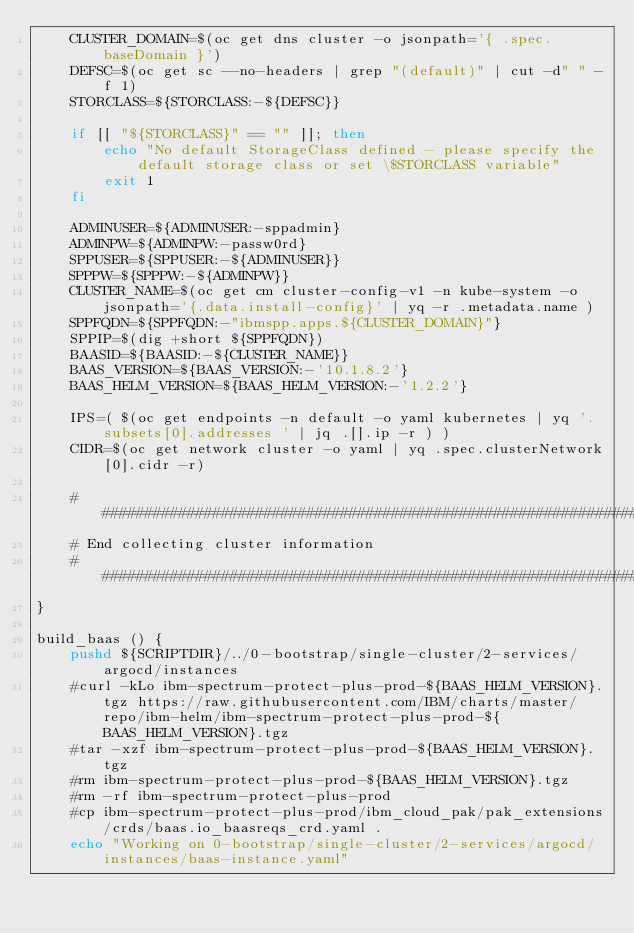<code> <loc_0><loc_0><loc_500><loc_500><_Bash_>    CLUSTER_DOMAIN=$(oc get dns cluster -o jsonpath='{ .spec.baseDomain }')
    DEFSC=$(oc get sc --no-headers | grep "(default)" | cut -d" " -f 1)
    STORCLASS=${STORCLASS:-${DEFSC}}
    
    if [[ "${STORCLASS}" == "" ]]; then
        echo "No default StorageClass defined - please specify the default storage class or set \$STORCLASS variable"
        exit 1
    fi
    
    ADMINUSER=${ADMINUSER:-sppadmin}
    ADMINPW=${ADMINPW:-passw0rd}
    SPPUSER=${SPPUSER:-${ADMINUSER}}
    SPPPW=${SPPPW:-${ADMINPW}}
    CLUSTER_NAME=$(oc get cm cluster-config-v1 -n kube-system -o jsonpath='{.data.install-config}' | yq -r .metadata.name )
    SPPFQDN=${SPPFQDN:-"ibmspp.apps.${CLUSTER_DOMAIN}"}
    SPPIP=$(dig +short ${SPPFQDN})
    BAASID=${BAASID:-${CLUSTER_NAME}}
    BAAS_VERSION=${BAAS_VERSION:-'10.1.8.2'}
    BAAS_HELM_VERSION=${BAAS_HELM_VERSION:-'1.2.2'}    
    
    IPS=( $(oc get endpoints -n default -o yaml kubernetes | yq '.subsets[0].addresses ' | jq .[].ip -r ) )
    CIDR=$(oc get network cluster -o yaml | yq .spec.clusterNetwork[0].cidr -r)
    
    ##############################################################################
    # End collecting cluster information
    ##############################################################################
}

build_baas () {
    pushd ${SCRIPTDIR}/../0-bootstrap/single-cluster/2-services/argocd/instances
    #curl -kLo ibm-spectrum-protect-plus-prod-${BAAS_HELM_VERSION}.tgz https://raw.githubusercontent.com/IBM/charts/master/repo/ibm-helm/ibm-spectrum-protect-plus-prod-${BAAS_HELM_VERSION}.tgz
    #tar -xzf ibm-spectrum-protect-plus-prod-${BAAS_HELM_VERSION}.tgz   
    #rm ibm-spectrum-protect-plus-prod-${BAAS_HELM_VERSION}.tgz
    #rm -rf ibm-spectrum-protect-plus-prod
    #cp ibm-spectrum-protect-plus-prod/ibm_cloud_pak/pak_extensions/crds/baas.io_baasreqs_crd.yaml .
    echo "Working on 0-bootstrap/single-cluster/2-services/argocd/instances/baas-instance.yaml"</code> 